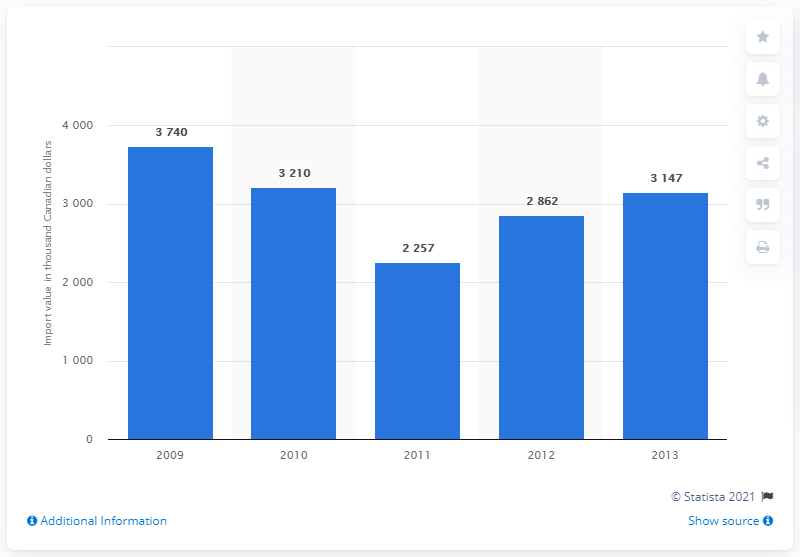List a handful of essential elements in this visual. Since 2011, the value of maple sugar and maple syrup imported into Switzerland has increased. 